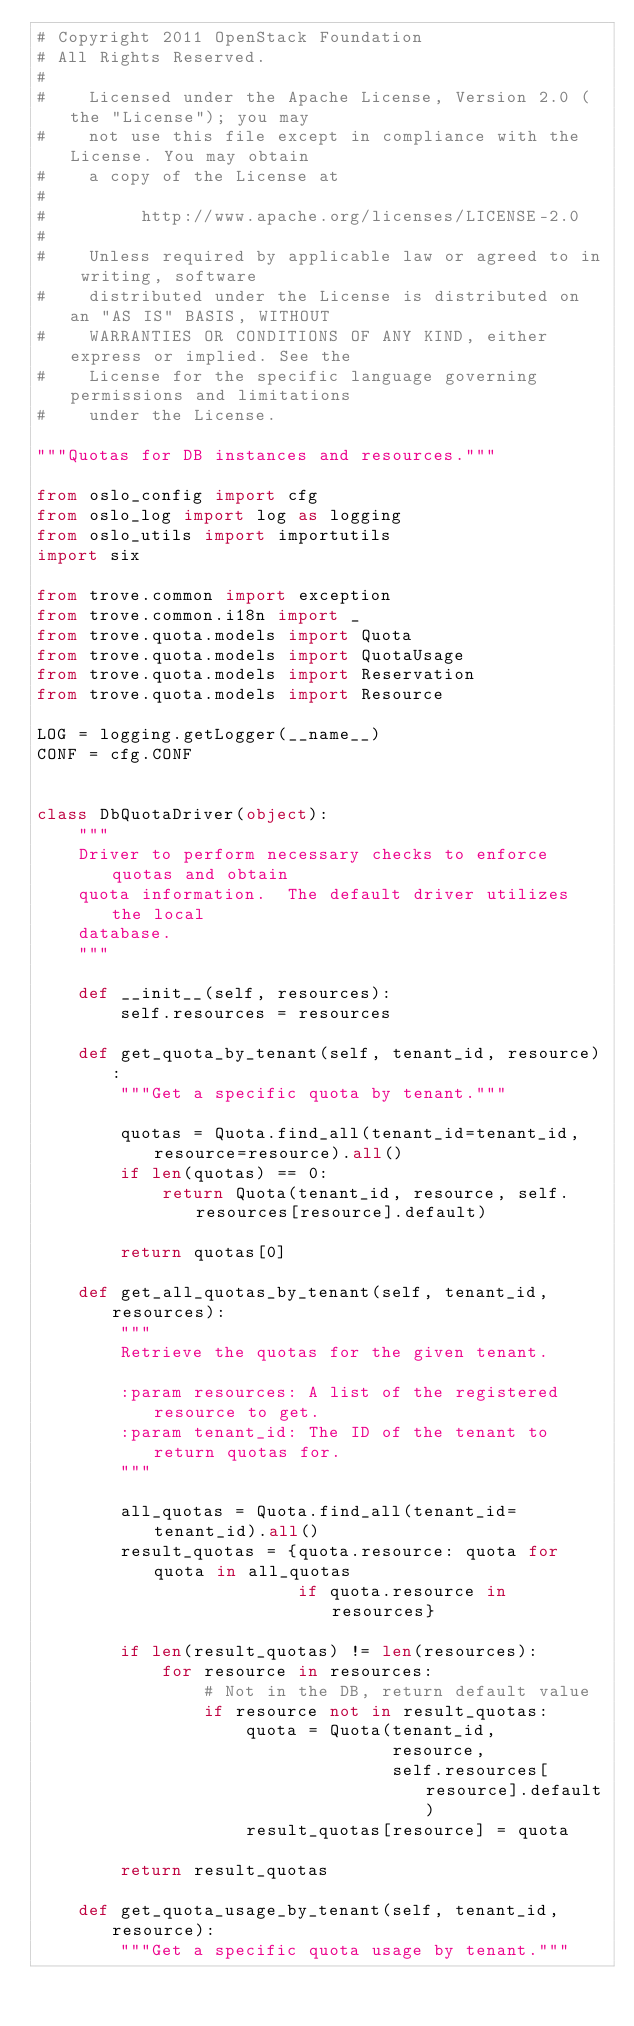Convert code to text. <code><loc_0><loc_0><loc_500><loc_500><_Python_># Copyright 2011 OpenStack Foundation
# All Rights Reserved.
#
#    Licensed under the Apache License, Version 2.0 (the "License"); you may
#    not use this file except in compliance with the License. You may obtain
#    a copy of the License at
#
#         http://www.apache.org/licenses/LICENSE-2.0
#
#    Unless required by applicable law or agreed to in writing, software
#    distributed under the License is distributed on an "AS IS" BASIS, WITHOUT
#    WARRANTIES OR CONDITIONS OF ANY KIND, either express or implied. See the
#    License for the specific language governing permissions and limitations
#    under the License.

"""Quotas for DB instances and resources."""

from oslo_config import cfg
from oslo_log import log as logging
from oslo_utils import importutils
import six

from trove.common import exception
from trove.common.i18n import _
from trove.quota.models import Quota
from trove.quota.models import QuotaUsage
from trove.quota.models import Reservation
from trove.quota.models import Resource

LOG = logging.getLogger(__name__)
CONF = cfg.CONF


class DbQuotaDriver(object):
    """
    Driver to perform necessary checks to enforce quotas and obtain
    quota information.  The default driver utilizes the local
    database.
    """

    def __init__(self, resources):
        self.resources = resources

    def get_quota_by_tenant(self, tenant_id, resource):
        """Get a specific quota by tenant."""

        quotas = Quota.find_all(tenant_id=tenant_id, resource=resource).all()
        if len(quotas) == 0:
            return Quota(tenant_id, resource, self.resources[resource].default)

        return quotas[0]

    def get_all_quotas_by_tenant(self, tenant_id, resources):
        """
        Retrieve the quotas for the given tenant.

        :param resources: A list of the registered resource to get.
        :param tenant_id: The ID of the tenant to return quotas for.
        """

        all_quotas = Quota.find_all(tenant_id=tenant_id).all()
        result_quotas = {quota.resource: quota for quota in all_quotas
                         if quota.resource in resources}

        if len(result_quotas) != len(resources):
            for resource in resources:
                # Not in the DB, return default value
                if resource not in result_quotas:
                    quota = Quota(tenant_id,
                                  resource,
                                  self.resources[resource].default)
                    result_quotas[resource] = quota

        return result_quotas

    def get_quota_usage_by_tenant(self, tenant_id, resource):
        """Get a specific quota usage by tenant."""
</code> 